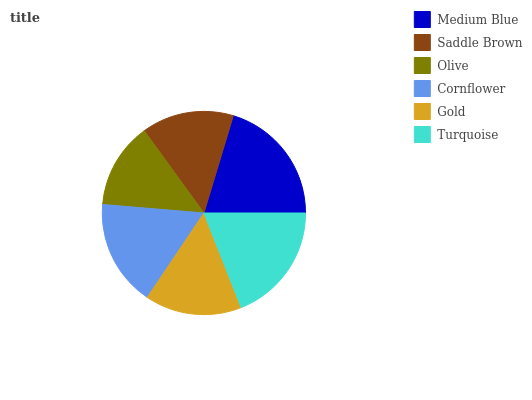Is Olive the minimum?
Answer yes or no. Yes. Is Medium Blue the maximum?
Answer yes or no. Yes. Is Saddle Brown the minimum?
Answer yes or no. No. Is Saddle Brown the maximum?
Answer yes or no. No. Is Medium Blue greater than Saddle Brown?
Answer yes or no. Yes. Is Saddle Brown less than Medium Blue?
Answer yes or no. Yes. Is Saddle Brown greater than Medium Blue?
Answer yes or no. No. Is Medium Blue less than Saddle Brown?
Answer yes or no. No. Is Cornflower the high median?
Answer yes or no. Yes. Is Gold the low median?
Answer yes or no. Yes. Is Olive the high median?
Answer yes or no. No. Is Saddle Brown the low median?
Answer yes or no. No. 